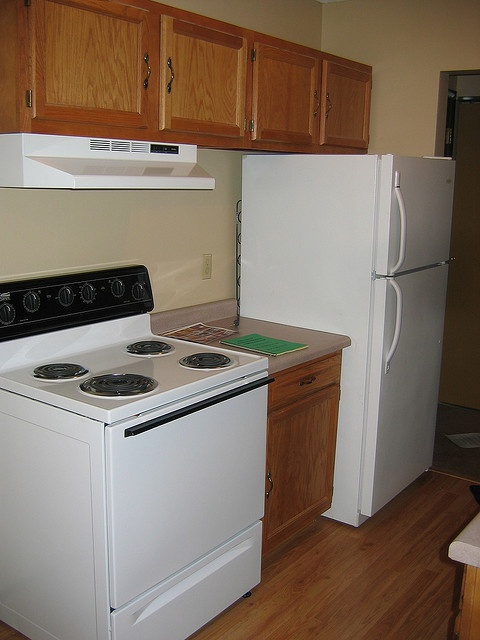Describe the objects in this image and their specific colors. I can see oven in maroon, darkgray, black, lightgray, and gray tones and refrigerator in maroon, darkgray, gray, and black tones in this image. 